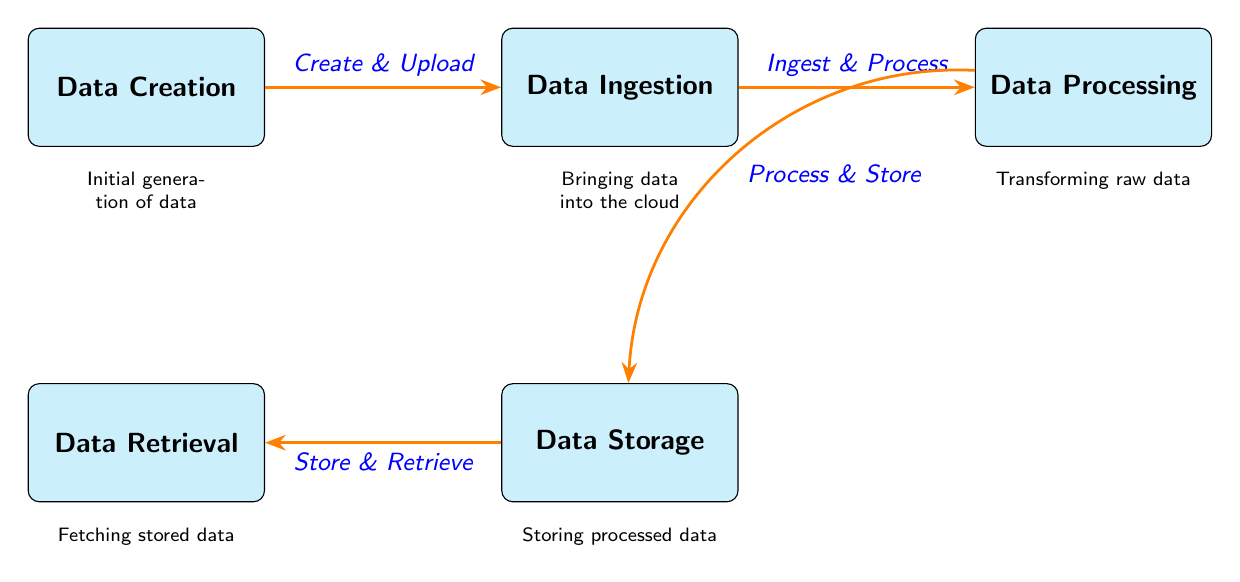What is the first step in the data transfer lifecycle? The diagram indicates that the first step is "Data Creation," which is positioned at the leftmost node.
Answer: Data Creation How many main processes are depicted in the diagram? By counting the box nodes in the diagram, there are five main processes (Data Creation, Data Ingestion, Data Processing, Data Storage, and Data Retrieval).
Answer: Five What relationship exists between Data Ingestion and Data Processing? The diagram shows an arrow labeled "Ingest & Process" connecting the Data Ingestion node to the Data Processing node, indicating a direct flow from one to the other.
Answer: Ingest & Process What happens to data after processing? According to the diagram, after data processing, the data is processed and stored, as shown by the connection to the Data Storage node with the label "Process & Store."
Answer: Process & Store How is data retrieved according to the diagram? The diagram illustrates the process of retrieving data through the "Store & Retrieve" action leading from Data Storage to Data Retrieval, indicating how stored data is fetched.
Answer: Store & Retrieve Which process comes between Data Ingestion and Data Storage? The order in the diagram indicates that Data Processing occurs right after Data Ingestion and before Data Storage.
Answer: Data Processing 